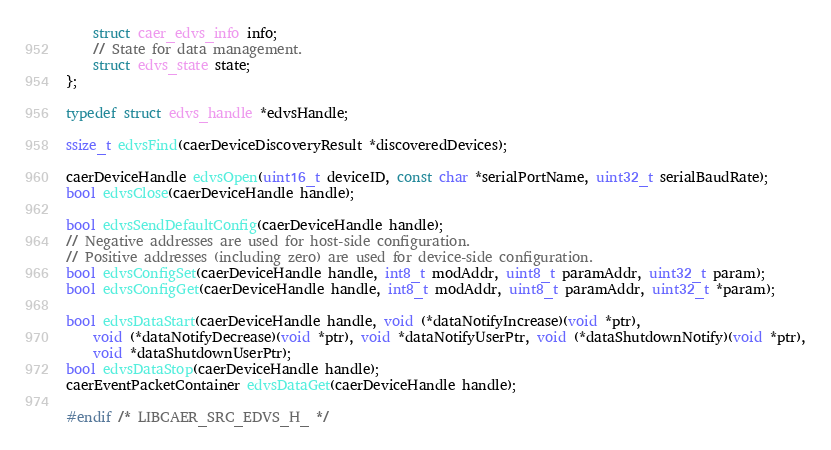Convert code to text. <code><loc_0><loc_0><loc_500><loc_500><_C_>	struct caer_edvs_info info;
	// State for data management.
	struct edvs_state state;
};

typedef struct edvs_handle *edvsHandle;

ssize_t edvsFind(caerDeviceDiscoveryResult *discoveredDevices);

caerDeviceHandle edvsOpen(uint16_t deviceID, const char *serialPortName, uint32_t serialBaudRate);
bool edvsClose(caerDeviceHandle handle);

bool edvsSendDefaultConfig(caerDeviceHandle handle);
// Negative addresses are used for host-side configuration.
// Positive addresses (including zero) are used for device-side configuration.
bool edvsConfigSet(caerDeviceHandle handle, int8_t modAddr, uint8_t paramAddr, uint32_t param);
bool edvsConfigGet(caerDeviceHandle handle, int8_t modAddr, uint8_t paramAddr, uint32_t *param);

bool edvsDataStart(caerDeviceHandle handle, void (*dataNotifyIncrease)(void *ptr),
	void (*dataNotifyDecrease)(void *ptr), void *dataNotifyUserPtr, void (*dataShutdownNotify)(void *ptr),
	void *dataShutdownUserPtr);
bool edvsDataStop(caerDeviceHandle handle);
caerEventPacketContainer edvsDataGet(caerDeviceHandle handle);

#endif /* LIBCAER_SRC_EDVS_H_ */
</code> 